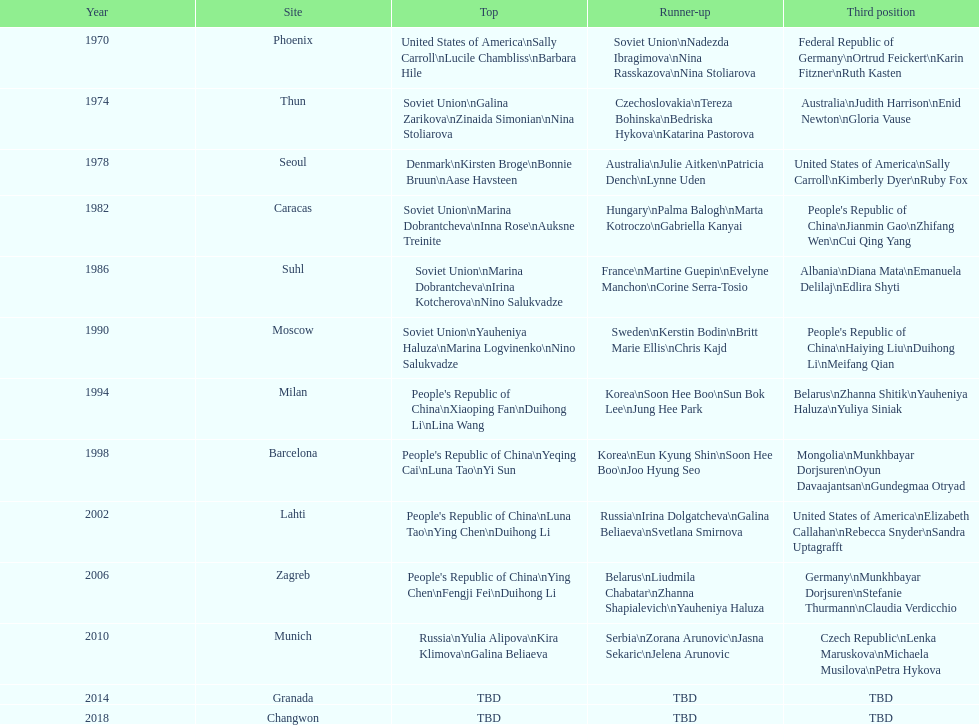How many world championships had the soviet union won first place in in the 25 metre pistol women's world championship? 4. 